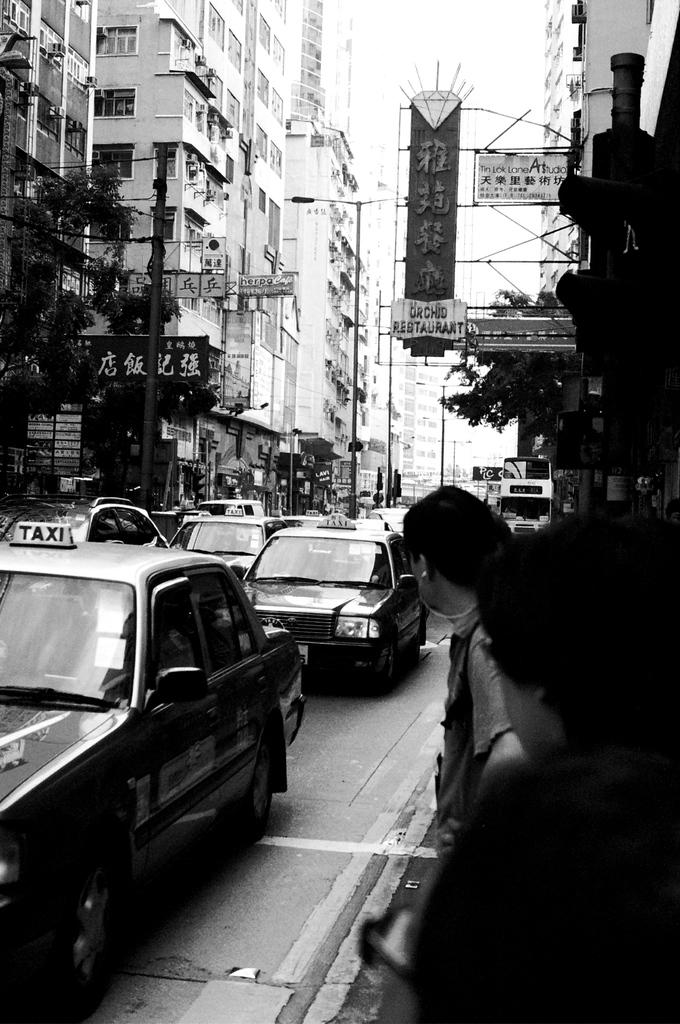<image>
Describe the image concisely. a black and white photo with taxi cars in the street 